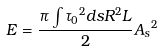Convert formula to latex. <formula><loc_0><loc_0><loc_500><loc_500>E = \frac { { \pi } \int { { { \tau } _ { 0 } } ^ { 2 } d s } R ^ { 2 } L } { 2 } { A _ { s } } ^ { 2 }</formula> 